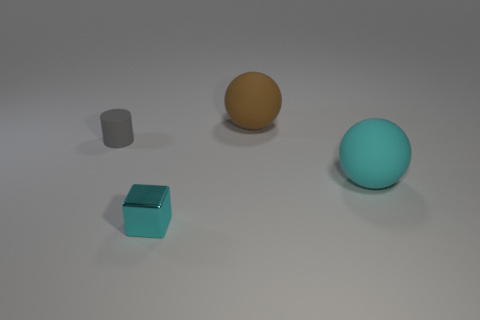What number of other objects are there of the same color as the tiny shiny thing?
Provide a succinct answer. 1. There is a large thing that is the same color as the tiny metal block; what material is it?
Ensure brevity in your answer.  Rubber. There is a rubber thing to the left of the big brown matte sphere; is its size the same as the cyan object to the left of the big brown sphere?
Make the answer very short. Yes. There is a rubber object in front of the gray rubber cylinder; what is its shape?
Offer a terse response. Sphere. What material is the big cyan thing that is the same shape as the brown rubber thing?
Provide a short and direct response. Rubber. There is a cyan object that is right of the block; is it the same size as the matte cylinder?
Keep it short and to the point. No. How many tiny gray objects are in front of the brown rubber sphere?
Your answer should be very brief. 1. Is the number of matte cylinders that are to the right of the small shiny object less than the number of cylinders in front of the cylinder?
Your answer should be very brief. No. How many purple blocks are there?
Give a very brief answer. 0. The large matte object that is behind the large cyan rubber ball is what color?
Your answer should be very brief. Brown. 